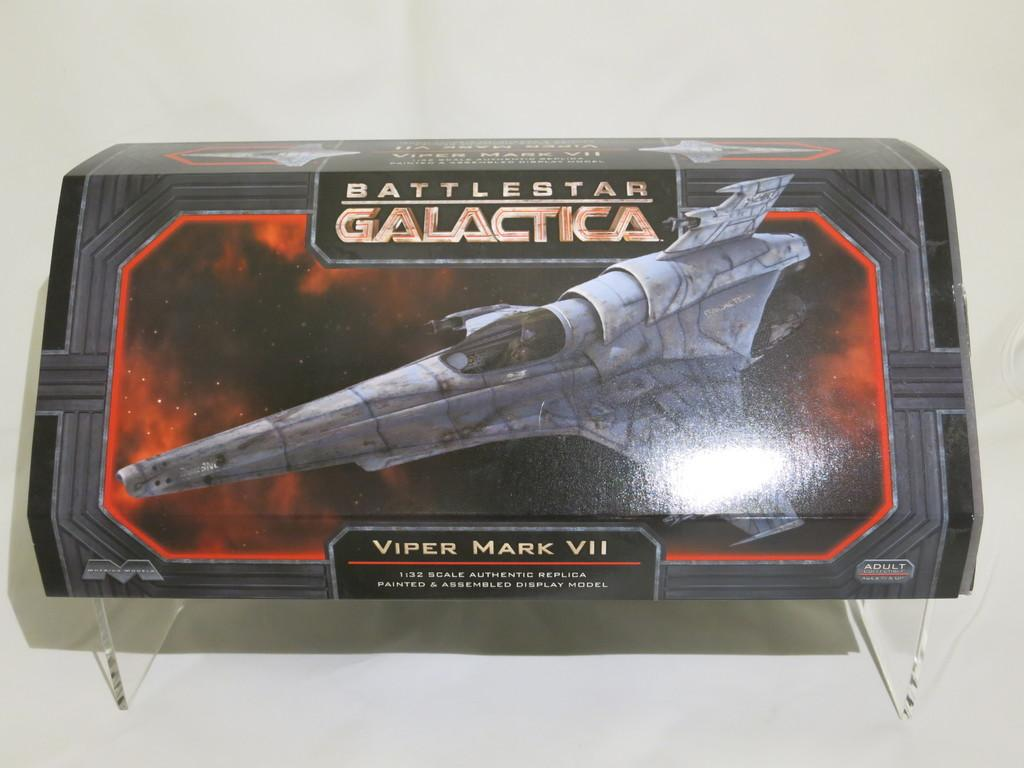<image>
Offer a succinct explanation of the picture presented. a painted and assembled Battlestar galactica model is on the table 